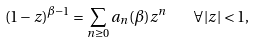Convert formula to latex. <formula><loc_0><loc_0><loc_500><loc_500>( 1 - z ) ^ { \beta - 1 } = \sum _ { n \geq 0 } a _ { n } ( \beta ) z ^ { n } \quad \forall | z | < 1 ,</formula> 